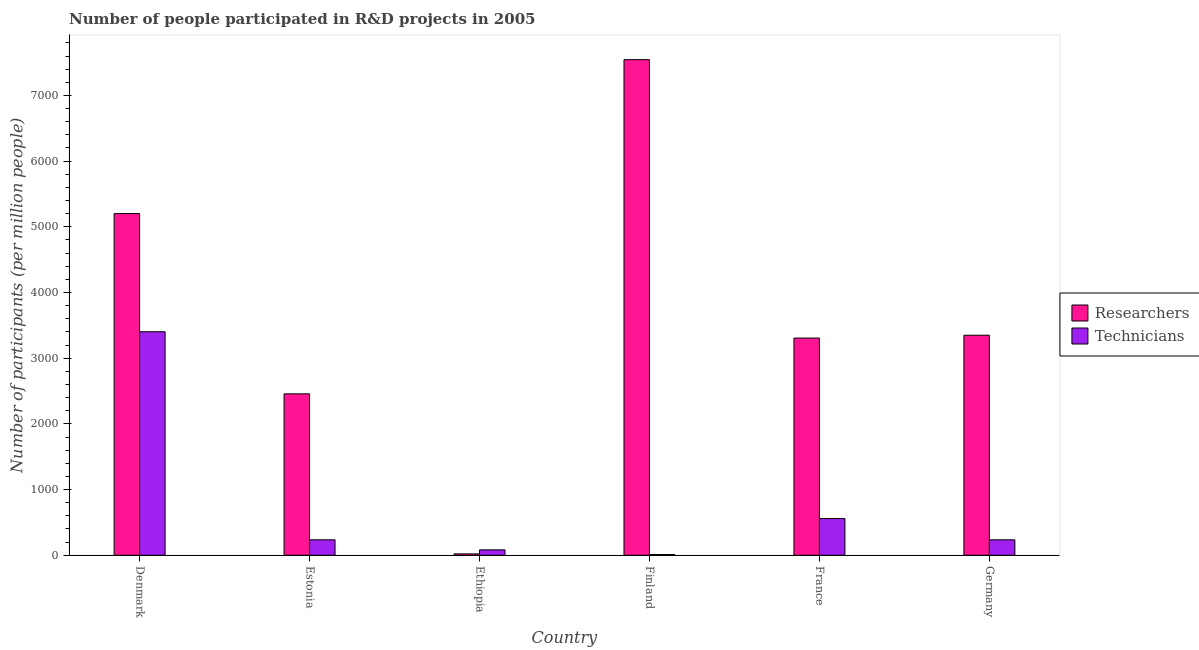How many different coloured bars are there?
Ensure brevity in your answer.  2. How many groups of bars are there?
Your answer should be very brief. 6. Are the number of bars per tick equal to the number of legend labels?
Provide a succinct answer. Yes. Are the number of bars on each tick of the X-axis equal?
Offer a terse response. Yes. How many bars are there on the 2nd tick from the right?
Give a very brief answer. 2. In how many cases, is the number of bars for a given country not equal to the number of legend labels?
Your answer should be compact. 0. What is the number of researchers in Ethiopia?
Your response must be concise. 20.99. Across all countries, what is the maximum number of researchers?
Your answer should be very brief. 7544.65. Across all countries, what is the minimum number of researchers?
Give a very brief answer. 20.99. In which country was the number of researchers maximum?
Provide a succinct answer. Finland. What is the total number of researchers in the graph?
Your answer should be very brief. 2.19e+04. What is the difference between the number of technicians in Estonia and that in Ethiopia?
Make the answer very short. 153.16. What is the difference between the number of technicians in Denmark and the number of researchers in Germany?
Provide a short and direct response. 52.8. What is the average number of technicians per country?
Your answer should be compact. 754.14. What is the difference between the number of researchers and number of technicians in Germany?
Make the answer very short. 3114.6. In how many countries, is the number of researchers greater than 1400 ?
Your answer should be compact. 5. What is the ratio of the number of technicians in Denmark to that in Estonia?
Your response must be concise. 14.45. Is the number of researchers in Denmark less than that in Germany?
Keep it short and to the point. No. Is the difference between the number of researchers in Ethiopia and Finland greater than the difference between the number of technicians in Ethiopia and Finland?
Offer a terse response. No. What is the difference between the highest and the second highest number of technicians?
Make the answer very short. 2843.39. What is the difference between the highest and the lowest number of researchers?
Offer a terse response. 7523.66. What does the 1st bar from the left in Germany represents?
Offer a terse response. Researchers. What does the 1st bar from the right in Denmark represents?
Your answer should be compact. Technicians. What is the difference between two consecutive major ticks on the Y-axis?
Make the answer very short. 1000. Does the graph contain any zero values?
Give a very brief answer. No. How are the legend labels stacked?
Your answer should be very brief. Vertical. What is the title of the graph?
Make the answer very short. Number of people participated in R&D projects in 2005. What is the label or title of the X-axis?
Your response must be concise. Country. What is the label or title of the Y-axis?
Make the answer very short. Number of participants (per million people). What is the Number of participants (per million people) of Researchers in Denmark?
Give a very brief answer. 5201.29. What is the Number of participants (per million people) of Technicians in Denmark?
Ensure brevity in your answer.  3402.45. What is the Number of participants (per million people) in Researchers in Estonia?
Ensure brevity in your answer.  2457.1. What is the Number of participants (per million people) of Technicians in Estonia?
Give a very brief answer. 235.4. What is the Number of participants (per million people) in Researchers in Ethiopia?
Ensure brevity in your answer.  20.99. What is the Number of participants (per million people) in Technicians in Ethiopia?
Give a very brief answer. 82.24. What is the Number of participants (per million people) in Researchers in Finland?
Offer a terse response. 7544.65. What is the Number of participants (per million people) in Technicians in Finland?
Provide a succinct answer. 10.66. What is the Number of participants (per million people) in Researchers in France?
Offer a terse response. 3306.68. What is the Number of participants (per million people) in Technicians in France?
Offer a terse response. 559.06. What is the Number of participants (per million people) of Researchers in Germany?
Offer a very short reply. 3349.65. What is the Number of participants (per million people) in Technicians in Germany?
Give a very brief answer. 235.05. Across all countries, what is the maximum Number of participants (per million people) of Researchers?
Give a very brief answer. 7544.65. Across all countries, what is the maximum Number of participants (per million people) in Technicians?
Your response must be concise. 3402.45. Across all countries, what is the minimum Number of participants (per million people) in Researchers?
Your answer should be very brief. 20.99. Across all countries, what is the minimum Number of participants (per million people) of Technicians?
Provide a succinct answer. 10.66. What is the total Number of participants (per million people) of Researchers in the graph?
Give a very brief answer. 2.19e+04. What is the total Number of participants (per million people) of Technicians in the graph?
Your answer should be compact. 4524.85. What is the difference between the Number of participants (per million people) of Researchers in Denmark and that in Estonia?
Ensure brevity in your answer.  2744.19. What is the difference between the Number of participants (per million people) of Technicians in Denmark and that in Estonia?
Offer a terse response. 3167.05. What is the difference between the Number of participants (per million people) in Researchers in Denmark and that in Ethiopia?
Offer a very short reply. 5180.3. What is the difference between the Number of participants (per million people) of Technicians in Denmark and that in Ethiopia?
Keep it short and to the point. 3320.21. What is the difference between the Number of participants (per million people) of Researchers in Denmark and that in Finland?
Keep it short and to the point. -2343.35. What is the difference between the Number of participants (per million people) of Technicians in Denmark and that in Finland?
Your answer should be very brief. 3391.79. What is the difference between the Number of participants (per million people) in Researchers in Denmark and that in France?
Make the answer very short. 1894.61. What is the difference between the Number of participants (per million people) of Technicians in Denmark and that in France?
Keep it short and to the point. 2843.39. What is the difference between the Number of participants (per million people) in Researchers in Denmark and that in Germany?
Provide a short and direct response. 1851.65. What is the difference between the Number of participants (per million people) of Technicians in Denmark and that in Germany?
Give a very brief answer. 3167.4. What is the difference between the Number of participants (per million people) of Researchers in Estonia and that in Ethiopia?
Offer a very short reply. 2436.11. What is the difference between the Number of participants (per million people) in Technicians in Estonia and that in Ethiopia?
Give a very brief answer. 153.16. What is the difference between the Number of participants (per million people) in Researchers in Estonia and that in Finland?
Your response must be concise. -5087.55. What is the difference between the Number of participants (per million people) of Technicians in Estonia and that in Finland?
Offer a very short reply. 224.73. What is the difference between the Number of participants (per million people) in Researchers in Estonia and that in France?
Ensure brevity in your answer.  -849.58. What is the difference between the Number of participants (per million people) in Technicians in Estonia and that in France?
Keep it short and to the point. -323.67. What is the difference between the Number of participants (per million people) of Researchers in Estonia and that in Germany?
Make the answer very short. -892.54. What is the difference between the Number of participants (per million people) in Technicians in Estonia and that in Germany?
Your response must be concise. 0.35. What is the difference between the Number of participants (per million people) of Researchers in Ethiopia and that in Finland?
Keep it short and to the point. -7523.66. What is the difference between the Number of participants (per million people) of Technicians in Ethiopia and that in Finland?
Ensure brevity in your answer.  71.58. What is the difference between the Number of participants (per million people) of Researchers in Ethiopia and that in France?
Ensure brevity in your answer.  -3285.69. What is the difference between the Number of participants (per million people) of Technicians in Ethiopia and that in France?
Keep it short and to the point. -476.83. What is the difference between the Number of participants (per million people) in Researchers in Ethiopia and that in Germany?
Your response must be concise. -3328.66. What is the difference between the Number of participants (per million people) of Technicians in Ethiopia and that in Germany?
Your response must be concise. -152.81. What is the difference between the Number of participants (per million people) of Researchers in Finland and that in France?
Make the answer very short. 4237.97. What is the difference between the Number of participants (per million people) of Technicians in Finland and that in France?
Give a very brief answer. -548.4. What is the difference between the Number of participants (per million people) in Researchers in Finland and that in Germany?
Offer a very short reply. 4195. What is the difference between the Number of participants (per million people) in Technicians in Finland and that in Germany?
Provide a succinct answer. -224.39. What is the difference between the Number of participants (per million people) in Researchers in France and that in Germany?
Your answer should be compact. -42.96. What is the difference between the Number of participants (per million people) of Technicians in France and that in Germany?
Make the answer very short. 324.01. What is the difference between the Number of participants (per million people) of Researchers in Denmark and the Number of participants (per million people) of Technicians in Estonia?
Your answer should be very brief. 4965.9. What is the difference between the Number of participants (per million people) of Researchers in Denmark and the Number of participants (per million people) of Technicians in Ethiopia?
Ensure brevity in your answer.  5119.06. What is the difference between the Number of participants (per million people) of Researchers in Denmark and the Number of participants (per million people) of Technicians in Finland?
Make the answer very short. 5190.63. What is the difference between the Number of participants (per million people) in Researchers in Denmark and the Number of participants (per million people) in Technicians in France?
Offer a terse response. 4642.23. What is the difference between the Number of participants (per million people) of Researchers in Denmark and the Number of participants (per million people) of Technicians in Germany?
Give a very brief answer. 4966.25. What is the difference between the Number of participants (per million people) of Researchers in Estonia and the Number of participants (per million people) of Technicians in Ethiopia?
Ensure brevity in your answer.  2374.87. What is the difference between the Number of participants (per million people) in Researchers in Estonia and the Number of participants (per million people) in Technicians in Finland?
Offer a terse response. 2446.44. What is the difference between the Number of participants (per million people) in Researchers in Estonia and the Number of participants (per million people) in Technicians in France?
Your response must be concise. 1898.04. What is the difference between the Number of participants (per million people) in Researchers in Estonia and the Number of participants (per million people) in Technicians in Germany?
Your answer should be very brief. 2222.05. What is the difference between the Number of participants (per million people) of Researchers in Ethiopia and the Number of participants (per million people) of Technicians in Finland?
Make the answer very short. 10.33. What is the difference between the Number of participants (per million people) of Researchers in Ethiopia and the Number of participants (per million people) of Technicians in France?
Your answer should be very brief. -538.07. What is the difference between the Number of participants (per million people) in Researchers in Ethiopia and the Number of participants (per million people) in Technicians in Germany?
Make the answer very short. -214.06. What is the difference between the Number of participants (per million people) of Researchers in Finland and the Number of participants (per million people) of Technicians in France?
Make the answer very short. 6985.59. What is the difference between the Number of participants (per million people) in Researchers in Finland and the Number of participants (per million people) in Technicians in Germany?
Your answer should be compact. 7309.6. What is the difference between the Number of participants (per million people) in Researchers in France and the Number of participants (per million people) in Technicians in Germany?
Offer a terse response. 3071.63. What is the average Number of participants (per million people) in Researchers per country?
Your answer should be compact. 3646.73. What is the average Number of participants (per million people) of Technicians per country?
Offer a very short reply. 754.14. What is the difference between the Number of participants (per million people) in Researchers and Number of participants (per million people) in Technicians in Denmark?
Your answer should be compact. 1798.85. What is the difference between the Number of participants (per million people) in Researchers and Number of participants (per million people) in Technicians in Estonia?
Your response must be concise. 2221.71. What is the difference between the Number of participants (per million people) of Researchers and Number of participants (per million people) of Technicians in Ethiopia?
Keep it short and to the point. -61.25. What is the difference between the Number of participants (per million people) of Researchers and Number of participants (per million people) of Technicians in Finland?
Provide a short and direct response. 7533.99. What is the difference between the Number of participants (per million people) of Researchers and Number of participants (per million people) of Technicians in France?
Provide a short and direct response. 2747.62. What is the difference between the Number of participants (per million people) of Researchers and Number of participants (per million people) of Technicians in Germany?
Make the answer very short. 3114.6. What is the ratio of the Number of participants (per million people) in Researchers in Denmark to that in Estonia?
Offer a very short reply. 2.12. What is the ratio of the Number of participants (per million people) of Technicians in Denmark to that in Estonia?
Your answer should be very brief. 14.45. What is the ratio of the Number of participants (per million people) in Researchers in Denmark to that in Ethiopia?
Make the answer very short. 247.8. What is the ratio of the Number of participants (per million people) in Technicians in Denmark to that in Ethiopia?
Give a very brief answer. 41.37. What is the ratio of the Number of participants (per million people) of Researchers in Denmark to that in Finland?
Your answer should be compact. 0.69. What is the ratio of the Number of participants (per million people) in Technicians in Denmark to that in Finland?
Ensure brevity in your answer.  319.14. What is the ratio of the Number of participants (per million people) of Researchers in Denmark to that in France?
Give a very brief answer. 1.57. What is the ratio of the Number of participants (per million people) of Technicians in Denmark to that in France?
Your answer should be very brief. 6.09. What is the ratio of the Number of participants (per million people) of Researchers in Denmark to that in Germany?
Keep it short and to the point. 1.55. What is the ratio of the Number of participants (per million people) in Technicians in Denmark to that in Germany?
Make the answer very short. 14.48. What is the ratio of the Number of participants (per million people) in Researchers in Estonia to that in Ethiopia?
Offer a very short reply. 117.06. What is the ratio of the Number of participants (per million people) in Technicians in Estonia to that in Ethiopia?
Provide a succinct answer. 2.86. What is the ratio of the Number of participants (per million people) of Researchers in Estonia to that in Finland?
Your answer should be very brief. 0.33. What is the ratio of the Number of participants (per million people) in Technicians in Estonia to that in Finland?
Your answer should be compact. 22.08. What is the ratio of the Number of participants (per million people) in Researchers in Estonia to that in France?
Your answer should be compact. 0.74. What is the ratio of the Number of participants (per million people) in Technicians in Estonia to that in France?
Your response must be concise. 0.42. What is the ratio of the Number of participants (per million people) in Researchers in Estonia to that in Germany?
Make the answer very short. 0.73. What is the ratio of the Number of participants (per million people) in Technicians in Estonia to that in Germany?
Provide a succinct answer. 1. What is the ratio of the Number of participants (per million people) in Researchers in Ethiopia to that in Finland?
Give a very brief answer. 0. What is the ratio of the Number of participants (per million people) in Technicians in Ethiopia to that in Finland?
Ensure brevity in your answer.  7.71. What is the ratio of the Number of participants (per million people) of Researchers in Ethiopia to that in France?
Your answer should be compact. 0.01. What is the ratio of the Number of participants (per million people) in Technicians in Ethiopia to that in France?
Your answer should be compact. 0.15. What is the ratio of the Number of participants (per million people) of Researchers in Ethiopia to that in Germany?
Offer a terse response. 0.01. What is the ratio of the Number of participants (per million people) in Technicians in Ethiopia to that in Germany?
Offer a very short reply. 0.35. What is the ratio of the Number of participants (per million people) of Researchers in Finland to that in France?
Make the answer very short. 2.28. What is the ratio of the Number of participants (per million people) in Technicians in Finland to that in France?
Give a very brief answer. 0.02. What is the ratio of the Number of participants (per million people) in Researchers in Finland to that in Germany?
Keep it short and to the point. 2.25. What is the ratio of the Number of participants (per million people) of Technicians in Finland to that in Germany?
Make the answer very short. 0.05. What is the ratio of the Number of participants (per million people) of Researchers in France to that in Germany?
Provide a succinct answer. 0.99. What is the ratio of the Number of participants (per million people) in Technicians in France to that in Germany?
Keep it short and to the point. 2.38. What is the difference between the highest and the second highest Number of participants (per million people) in Researchers?
Keep it short and to the point. 2343.35. What is the difference between the highest and the second highest Number of participants (per million people) in Technicians?
Provide a succinct answer. 2843.39. What is the difference between the highest and the lowest Number of participants (per million people) of Researchers?
Give a very brief answer. 7523.66. What is the difference between the highest and the lowest Number of participants (per million people) in Technicians?
Offer a terse response. 3391.79. 